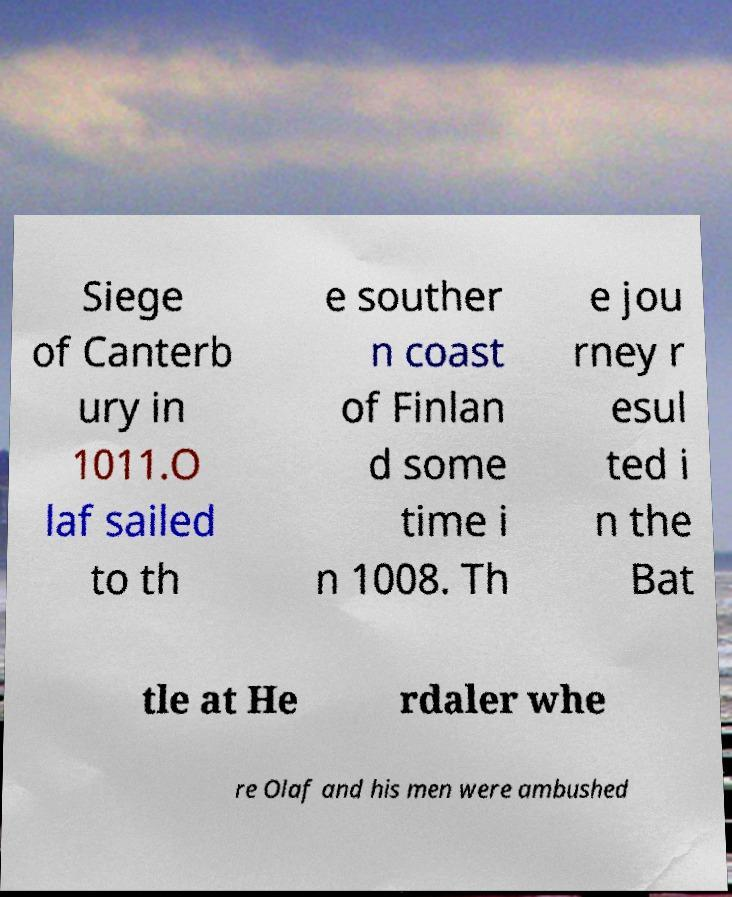For documentation purposes, I need the text within this image transcribed. Could you provide that? Siege of Canterb ury in 1011.O laf sailed to th e souther n coast of Finlan d some time i n 1008. Th e jou rney r esul ted i n the Bat tle at He rdaler whe re Olaf and his men were ambushed 